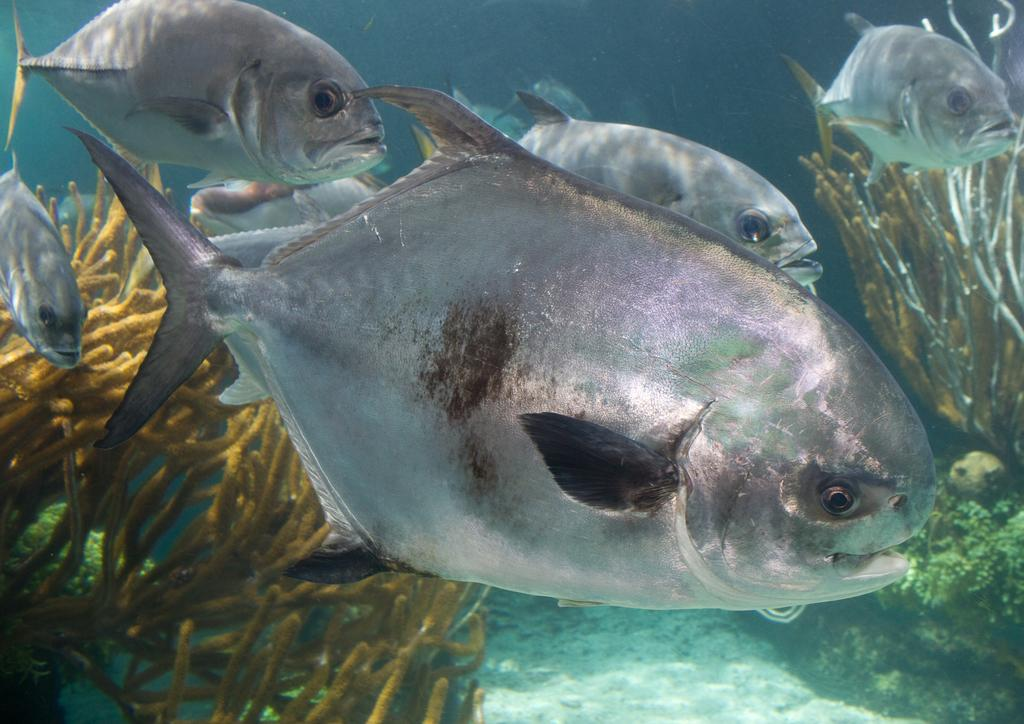What type of animals are in the image? There are fishes in the image. Where are the fishes located? The fishes are in the water. What can be seen at the bottom of the image? There are sea plants at the bottom of the image. What type of structure can be seen in the image? There is no structure present in the image; it features fishes in the water with sea plants at the bottom. What is the hose used for in the image? There is no hose present in the image. 